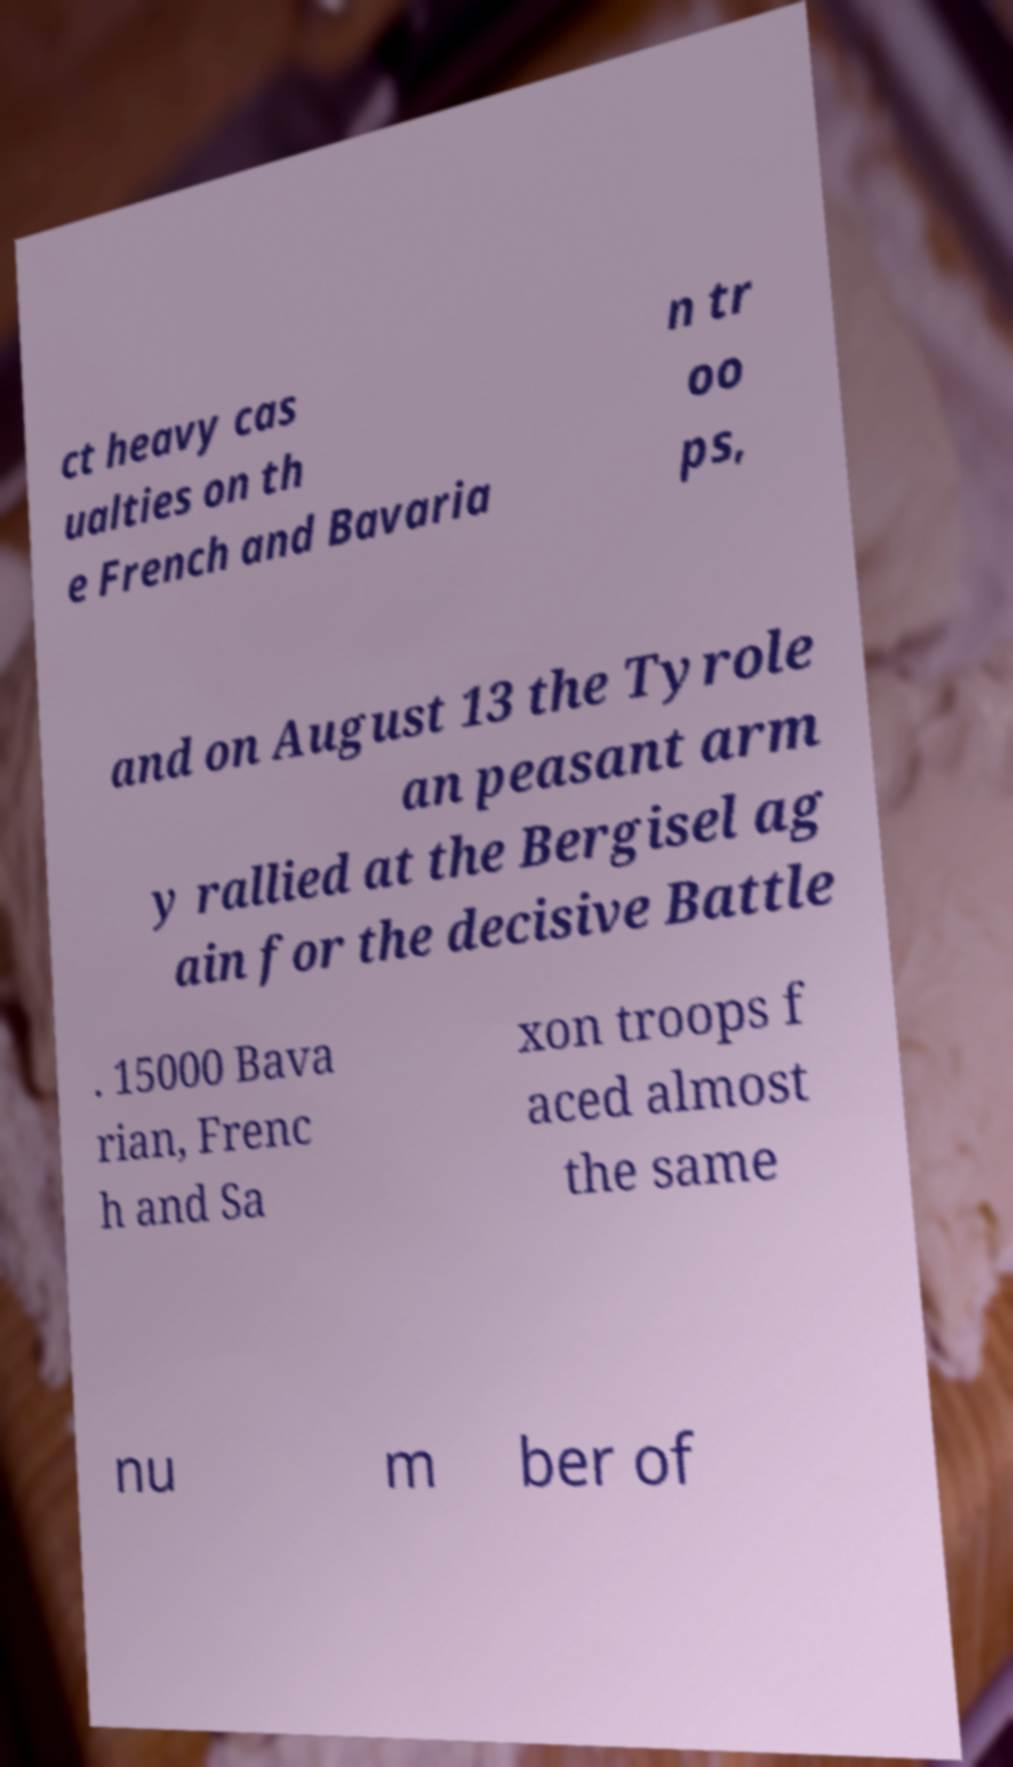For documentation purposes, I need the text within this image transcribed. Could you provide that? ct heavy cas ualties on th e French and Bavaria n tr oo ps, and on August 13 the Tyrole an peasant arm y rallied at the Bergisel ag ain for the decisive Battle . 15000 Bava rian, Frenc h and Sa xon troops f aced almost the same nu m ber of 